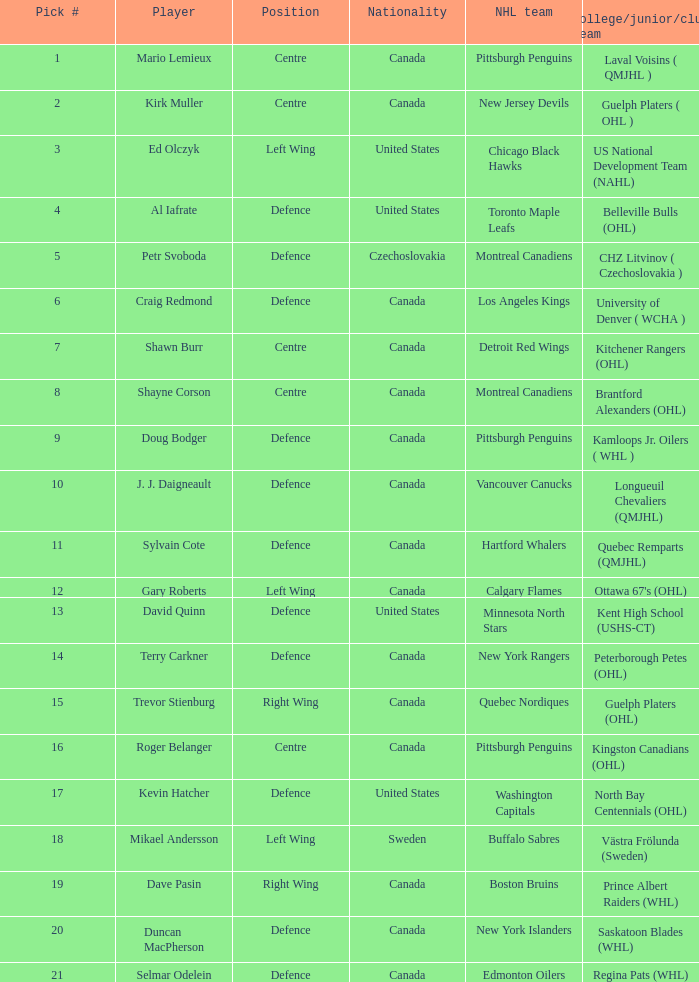The 18th draft pick belonged to which college team? Västra Frölunda (Sweden). Can you parse all the data within this table? {'header': ['Pick #', 'Player', 'Position', 'Nationality', 'NHL team', 'College/junior/club team'], 'rows': [['1', 'Mario Lemieux', 'Centre', 'Canada', 'Pittsburgh Penguins', 'Laval Voisins ( QMJHL )'], ['2', 'Kirk Muller', 'Centre', 'Canada', 'New Jersey Devils', 'Guelph Platers ( OHL )'], ['3', 'Ed Olczyk', 'Left Wing', 'United States', 'Chicago Black Hawks', 'US National Development Team (NAHL)'], ['4', 'Al Iafrate', 'Defence', 'United States', 'Toronto Maple Leafs', 'Belleville Bulls (OHL)'], ['5', 'Petr Svoboda', 'Defence', 'Czechoslovakia', 'Montreal Canadiens', 'CHZ Litvinov ( Czechoslovakia )'], ['6', 'Craig Redmond', 'Defence', 'Canada', 'Los Angeles Kings', 'University of Denver ( WCHA )'], ['7', 'Shawn Burr', 'Centre', 'Canada', 'Detroit Red Wings', 'Kitchener Rangers (OHL)'], ['8', 'Shayne Corson', 'Centre', 'Canada', 'Montreal Canadiens', 'Brantford Alexanders (OHL)'], ['9', 'Doug Bodger', 'Defence', 'Canada', 'Pittsburgh Penguins', 'Kamloops Jr. Oilers ( WHL )'], ['10', 'J. J. Daigneault', 'Defence', 'Canada', 'Vancouver Canucks', 'Longueuil Chevaliers (QMJHL)'], ['11', 'Sylvain Cote', 'Defence', 'Canada', 'Hartford Whalers', 'Quebec Remparts (QMJHL)'], ['12', 'Gary Roberts', 'Left Wing', 'Canada', 'Calgary Flames', "Ottawa 67's (OHL)"], ['13', 'David Quinn', 'Defence', 'United States', 'Minnesota North Stars', 'Kent High School (USHS-CT)'], ['14', 'Terry Carkner', 'Defence', 'Canada', 'New York Rangers', 'Peterborough Petes (OHL)'], ['15', 'Trevor Stienburg', 'Right Wing', 'Canada', 'Quebec Nordiques', 'Guelph Platers (OHL)'], ['16', 'Roger Belanger', 'Centre', 'Canada', 'Pittsburgh Penguins', 'Kingston Canadians (OHL)'], ['17', 'Kevin Hatcher', 'Defence', 'United States', 'Washington Capitals', 'North Bay Centennials (OHL)'], ['18', 'Mikael Andersson', 'Left Wing', 'Sweden', 'Buffalo Sabres', 'Västra Frölunda (Sweden)'], ['19', 'Dave Pasin', 'Right Wing', 'Canada', 'Boston Bruins', 'Prince Albert Raiders (WHL)'], ['20', 'Duncan MacPherson', 'Defence', 'Canada', 'New York Islanders', 'Saskatoon Blades (WHL)'], ['21', 'Selmar Odelein', 'Defence', 'Canada', 'Edmonton Oilers', 'Regina Pats (WHL)']]} 